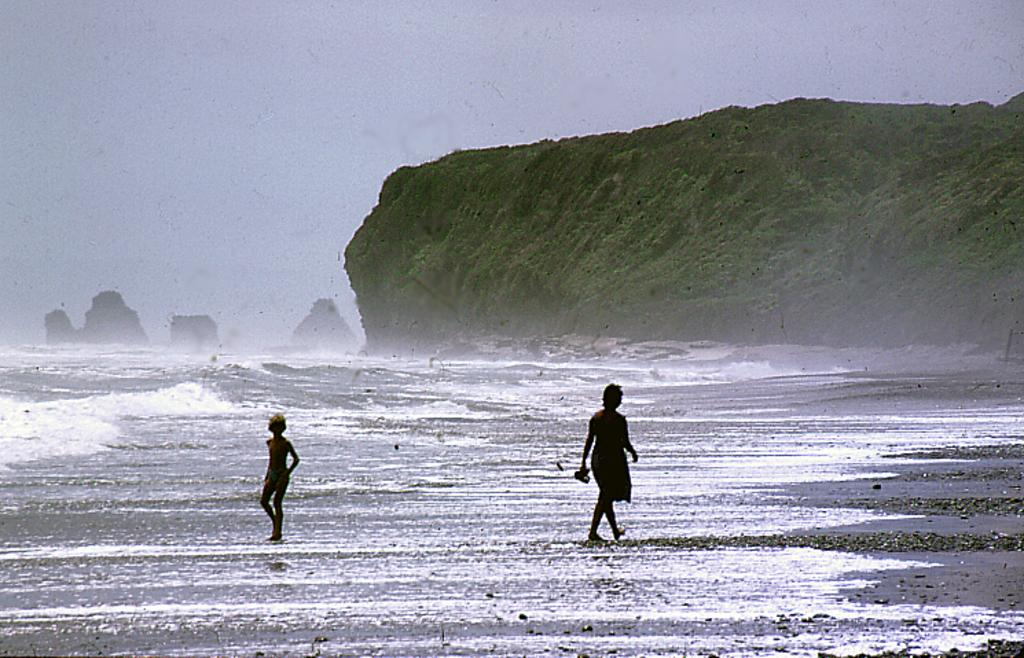How many people are in the image? There are two persons in the image. What are the persons doing in the image? The persons are walking on a seashore. What can be seen on the left side of the image? There is water and rocks visible on the left side of the image. What is visible in the background of the image? There is a hill and the sky visible in the background of the image. What type of curtain can be seen hanging from the hill in the image? There is no curtain present in the image; the hill is a natural formation in the background. 